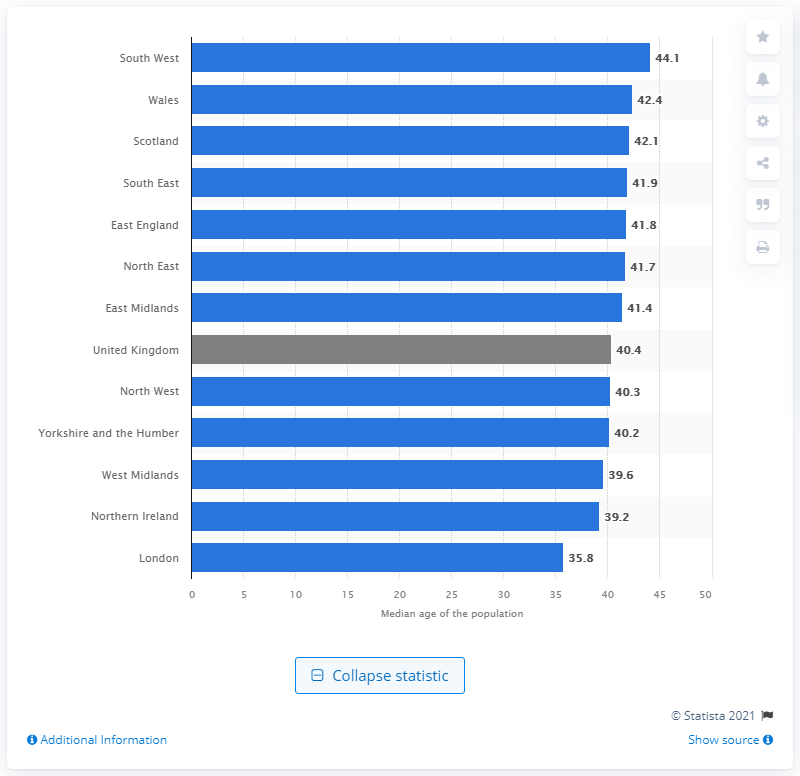Mention a couple of crucial points in this snapshot. London has the youngest average age among all cities. 